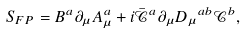Convert formula to latex. <formula><loc_0><loc_0><loc_500><loc_500>S _ { F P } = B ^ { a } \partial _ { \mu } A ^ { a } _ { \mu } + i \bar { \mathcal { C } } ^ { a } { \partial _ { \mu } D _ { \mu } } ^ { a b } { \mathcal { C } } ^ { b } ,</formula> 